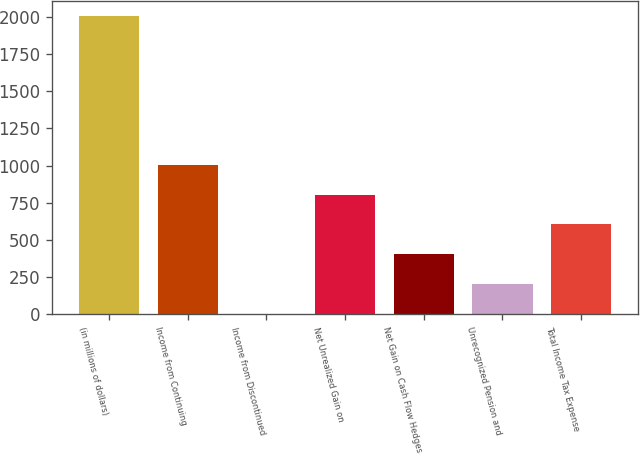Convert chart to OTSL. <chart><loc_0><loc_0><loc_500><loc_500><bar_chart><fcel>(in millions of dollars)<fcel>Income from Continuing<fcel>Income from Discontinued<fcel>Net Unrealized Gain on<fcel>Net Gain on Cash Flow Hedges<fcel>Unrecognized Pension and<fcel>Total Income Tax Expense<nl><fcel>2005<fcel>1005.55<fcel>6.1<fcel>805.66<fcel>405.88<fcel>205.99<fcel>605.77<nl></chart> 